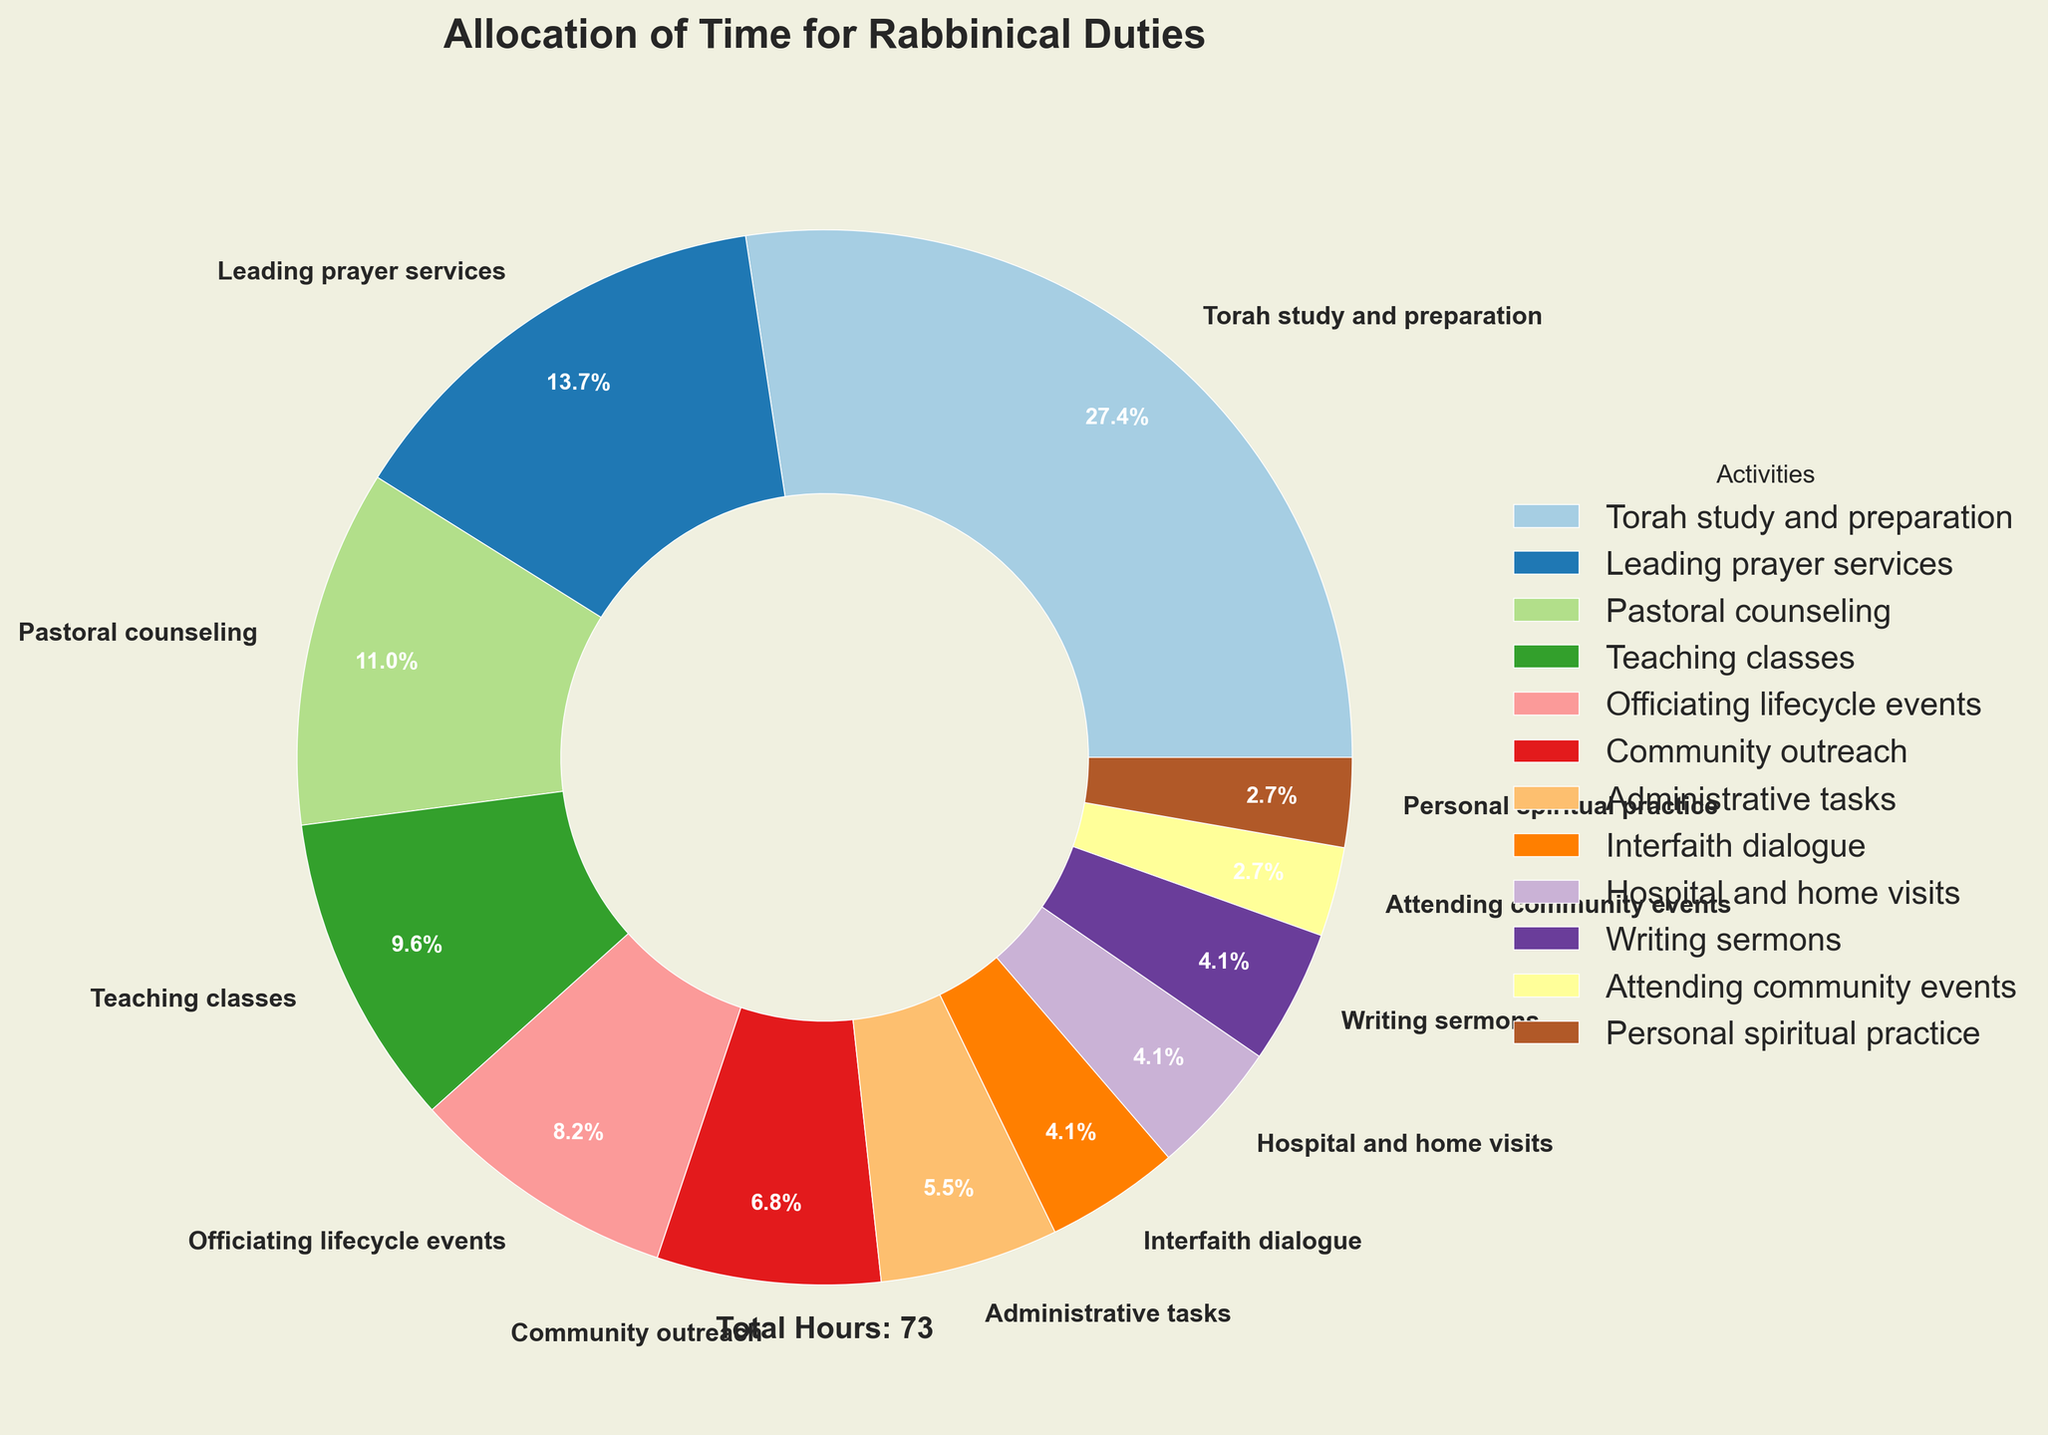What is the percentage of time spent on Torah study and preparation? To find the percentage of time spent on Torah study and preparation, look at the pie chart section labeled "Torah study and preparation". The percentage displayed on the chart is 37.7%.
Answer: 37.7% How many more hours per week are spent on leading prayer services compared to community outreach? Leading prayer services occupies 10 hours, while community outreach takes 5 hours. The difference in hours can be calculated by subtracting the time spent on community outreach from leading prayer services (10 - 5).
Answer: 5 hours Which activity takes up the smallest percentage of the rabbinical duties? To determine the smallest percentage, identify the activity with the smallest section in the pie chart. "Attending community events" and "Personal spiritual practice" both have the smallest sections, each constituting 3.8%.
Answer: Attending community events / Personal spiritual practice What percentage of the week is spent on pastoral counseling and hospital/home visits combined? Find the percentage for both pastoral counseling and hospital/home visits. Pastoral counseling is 15.1%, and hospital/home visits are 5.7%. Adding these percentages together (15.1 + 5.7) will give the combined percentage.
Answer: 20.8% Which activity occupies the third-largest amount of time per week? Examine the pie chart sections by their relative size. The largest is "Torah study and preparation" (20 hours), the second largest is "Leading prayer services" (10 hours), and the third largest is "Pastoral counseling" (8 hours).
Answer: Pastoral counseling How much more time in hours is spent on administrative tasks compared to interfaith dialogue? Administrative tasks take up 4 hours, and interfaith dialogue takes up 3 hours. Subtract the hours spent on interfaith dialogue from the hours spent on administrative tasks (4 - 3).
Answer: 1 hour What portion of the total time is dedicated to teaching classes compared to the total hours? Teaching classes takes 7 hours out of the total 73 hours. To find the portion, divide the hours for teaching classes by the total hours (7 / 73) and multiply by 100 to convert to percentage.
Answer: 9.6% What activities together make up about 20% of the total time? Look for activities whose combined hours make up approximately 20% of the total. Interfaith dialogue, hospital/home visits, writing sermons, attending community events, and personal spiritual practice together form 21 hours: (3 + 3 + 3 + 2 + 2), which is 28.8% of the total. Thus, slightly exceeding 20%.
Answer: Interfaith dialogue, hospital/home visits, writing sermons, attending community events, personal spiritual practice Which activity has a section colored in a lighter green shade? Without access to the actual color information from the chart, this cannot be answered definitively. Yet, the data structure of the script indicates a continuous color palette for different wedges. Thus, no concise answer can be provided based on color alone.
Answer: Not answerable 